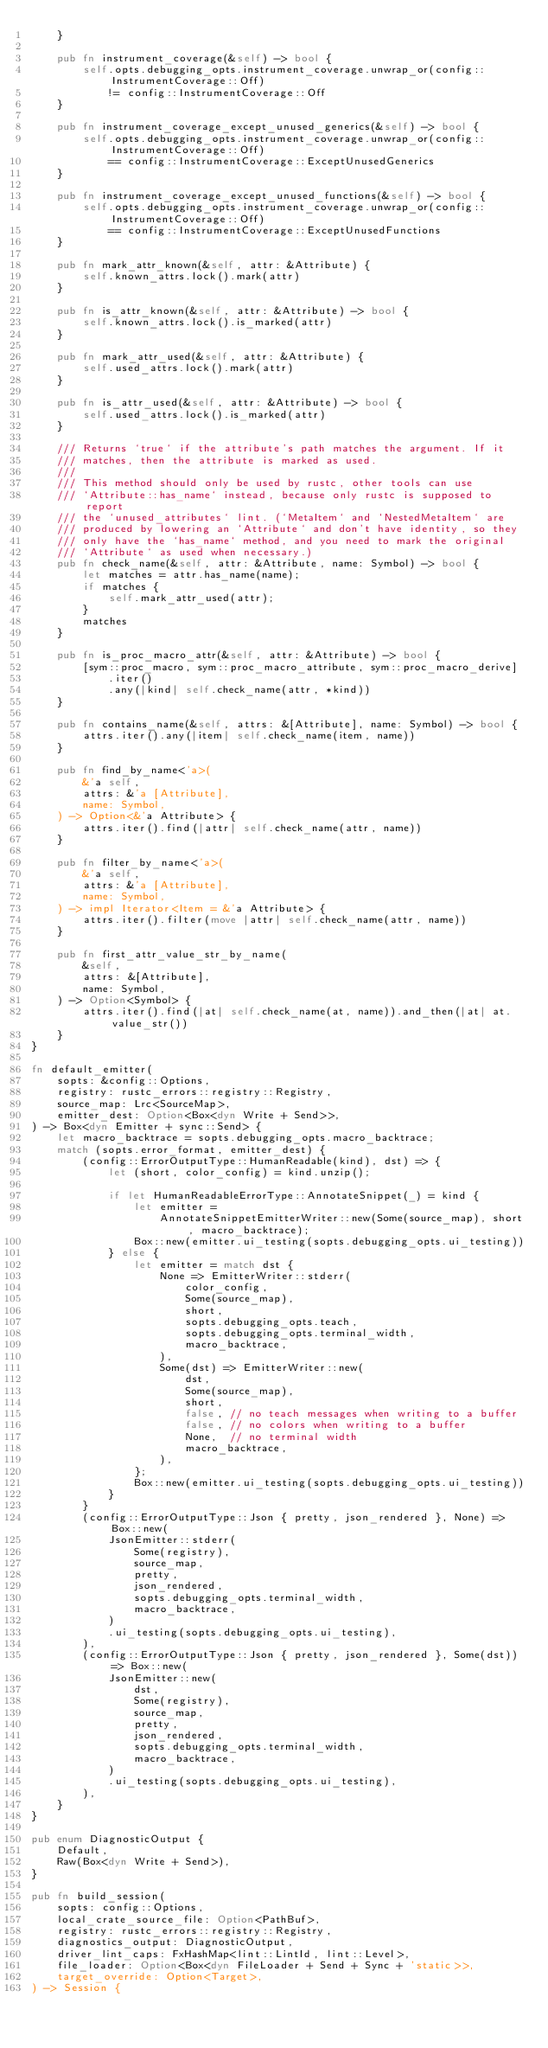Convert code to text. <code><loc_0><loc_0><loc_500><loc_500><_Rust_>    }

    pub fn instrument_coverage(&self) -> bool {
        self.opts.debugging_opts.instrument_coverage.unwrap_or(config::InstrumentCoverage::Off)
            != config::InstrumentCoverage::Off
    }

    pub fn instrument_coverage_except_unused_generics(&self) -> bool {
        self.opts.debugging_opts.instrument_coverage.unwrap_or(config::InstrumentCoverage::Off)
            == config::InstrumentCoverage::ExceptUnusedGenerics
    }

    pub fn instrument_coverage_except_unused_functions(&self) -> bool {
        self.opts.debugging_opts.instrument_coverage.unwrap_or(config::InstrumentCoverage::Off)
            == config::InstrumentCoverage::ExceptUnusedFunctions
    }

    pub fn mark_attr_known(&self, attr: &Attribute) {
        self.known_attrs.lock().mark(attr)
    }

    pub fn is_attr_known(&self, attr: &Attribute) -> bool {
        self.known_attrs.lock().is_marked(attr)
    }

    pub fn mark_attr_used(&self, attr: &Attribute) {
        self.used_attrs.lock().mark(attr)
    }

    pub fn is_attr_used(&self, attr: &Attribute) -> bool {
        self.used_attrs.lock().is_marked(attr)
    }

    /// Returns `true` if the attribute's path matches the argument. If it
    /// matches, then the attribute is marked as used.
    ///
    /// This method should only be used by rustc, other tools can use
    /// `Attribute::has_name` instead, because only rustc is supposed to report
    /// the `unused_attributes` lint. (`MetaItem` and `NestedMetaItem` are
    /// produced by lowering an `Attribute` and don't have identity, so they
    /// only have the `has_name` method, and you need to mark the original
    /// `Attribute` as used when necessary.)
    pub fn check_name(&self, attr: &Attribute, name: Symbol) -> bool {
        let matches = attr.has_name(name);
        if matches {
            self.mark_attr_used(attr);
        }
        matches
    }

    pub fn is_proc_macro_attr(&self, attr: &Attribute) -> bool {
        [sym::proc_macro, sym::proc_macro_attribute, sym::proc_macro_derive]
            .iter()
            .any(|kind| self.check_name(attr, *kind))
    }

    pub fn contains_name(&self, attrs: &[Attribute], name: Symbol) -> bool {
        attrs.iter().any(|item| self.check_name(item, name))
    }

    pub fn find_by_name<'a>(
        &'a self,
        attrs: &'a [Attribute],
        name: Symbol,
    ) -> Option<&'a Attribute> {
        attrs.iter().find(|attr| self.check_name(attr, name))
    }

    pub fn filter_by_name<'a>(
        &'a self,
        attrs: &'a [Attribute],
        name: Symbol,
    ) -> impl Iterator<Item = &'a Attribute> {
        attrs.iter().filter(move |attr| self.check_name(attr, name))
    }

    pub fn first_attr_value_str_by_name(
        &self,
        attrs: &[Attribute],
        name: Symbol,
    ) -> Option<Symbol> {
        attrs.iter().find(|at| self.check_name(at, name)).and_then(|at| at.value_str())
    }
}

fn default_emitter(
    sopts: &config::Options,
    registry: rustc_errors::registry::Registry,
    source_map: Lrc<SourceMap>,
    emitter_dest: Option<Box<dyn Write + Send>>,
) -> Box<dyn Emitter + sync::Send> {
    let macro_backtrace = sopts.debugging_opts.macro_backtrace;
    match (sopts.error_format, emitter_dest) {
        (config::ErrorOutputType::HumanReadable(kind), dst) => {
            let (short, color_config) = kind.unzip();

            if let HumanReadableErrorType::AnnotateSnippet(_) = kind {
                let emitter =
                    AnnotateSnippetEmitterWriter::new(Some(source_map), short, macro_backtrace);
                Box::new(emitter.ui_testing(sopts.debugging_opts.ui_testing))
            } else {
                let emitter = match dst {
                    None => EmitterWriter::stderr(
                        color_config,
                        Some(source_map),
                        short,
                        sopts.debugging_opts.teach,
                        sopts.debugging_opts.terminal_width,
                        macro_backtrace,
                    ),
                    Some(dst) => EmitterWriter::new(
                        dst,
                        Some(source_map),
                        short,
                        false, // no teach messages when writing to a buffer
                        false, // no colors when writing to a buffer
                        None,  // no terminal width
                        macro_backtrace,
                    ),
                };
                Box::new(emitter.ui_testing(sopts.debugging_opts.ui_testing))
            }
        }
        (config::ErrorOutputType::Json { pretty, json_rendered }, None) => Box::new(
            JsonEmitter::stderr(
                Some(registry),
                source_map,
                pretty,
                json_rendered,
                sopts.debugging_opts.terminal_width,
                macro_backtrace,
            )
            .ui_testing(sopts.debugging_opts.ui_testing),
        ),
        (config::ErrorOutputType::Json { pretty, json_rendered }, Some(dst)) => Box::new(
            JsonEmitter::new(
                dst,
                Some(registry),
                source_map,
                pretty,
                json_rendered,
                sopts.debugging_opts.terminal_width,
                macro_backtrace,
            )
            .ui_testing(sopts.debugging_opts.ui_testing),
        ),
    }
}

pub enum DiagnosticOutput {
    Default,
    Raw(Box<dyn Write + Send>),
}

pub fn build_session(
    sopts: config::Options,
    local_crate_source_file: Option<PathBuf>,
    registry: rustc_errors::registry::Registry,
    diagnostics_output: DiagnosticOutput,
    driver_lint_caps: FxHashMap<lint::LintId, lint::Level>,
    file_loader: Option<Box<dyn FileLoader + Send + Sync + 'static>>,
    target_override: Option<Target>,
) -> Session {</code> 